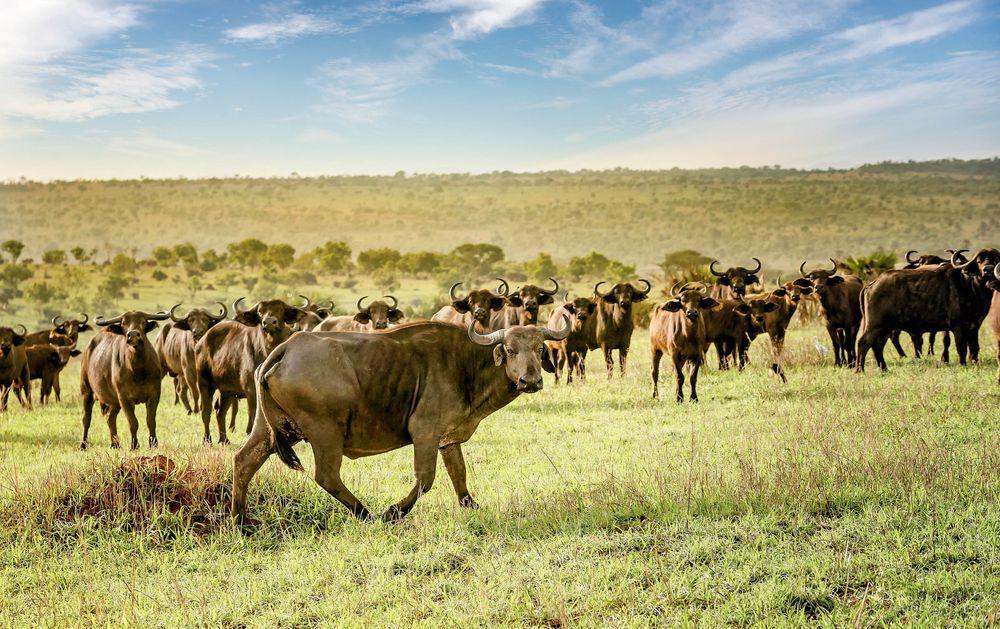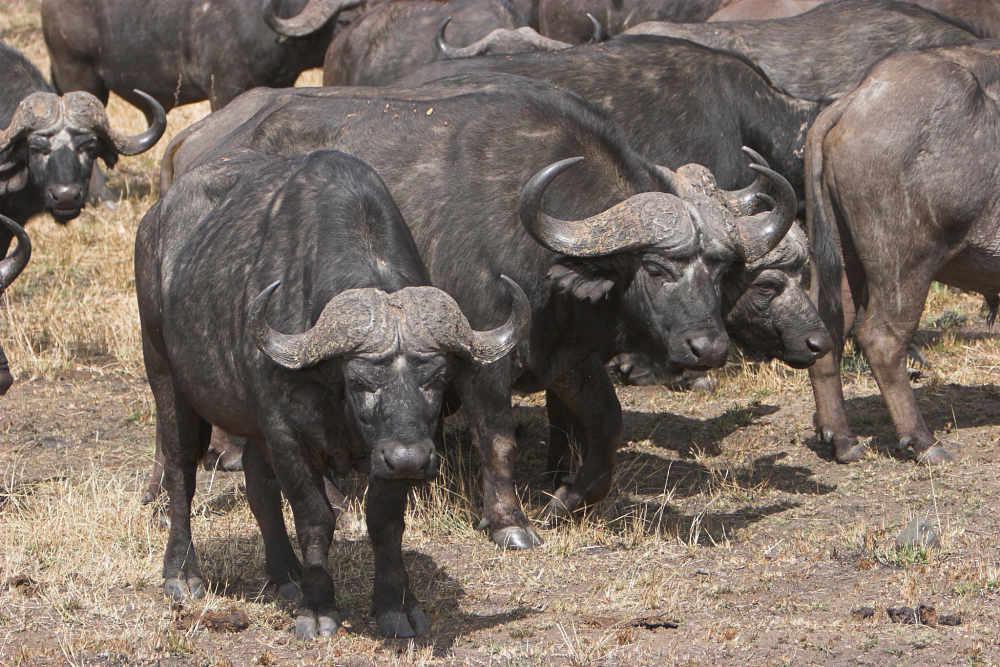The first image is the image on the left, the second image is the image on the right. Given the left and right images, does the statement "There is at least one white bird in the right image." hold true? Answer yes or no. No. The first image is the image on the left, the second image is the image on the right. Assess this claim about the two images: "All water buffalo are standing, and no water buffalo are in a scene with other types of mammals.". Correct or not? Answer yes or no. Yes. 